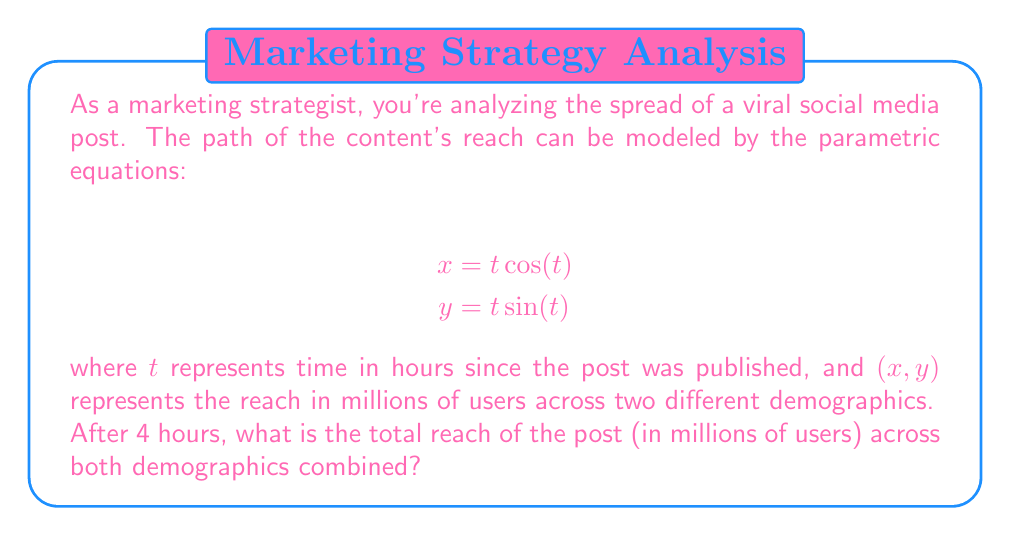Can you solve this math problem? To solve this problem, we need to follow these steps:

1) First, we need to calculate the x and y coordinates at t = 4 hours:

   For x: $x = t \cos(t) = 4 \cos(4)$
   For y: $y = t \sin(t) = 4 \sin(4)$

2) To find the actual values, we need to evaluate these:

   $x = 4 \cos(4) \approx -1.5136$ million users
   $y = 4 \sin(4) \approx 3.6370$ million users

3) The total reach is the distance from the origin to this point, which we can calculate using the Pythagorean theorem:

   $$\text{Total Reach} = \sqrt{x^2 + y^2}$$

4) Substituting our values:

   $$\text{Total Reach} = \sqrt{(-1.5136)^2 + (3.6370)^2}$$

5) Calculating:

   $$\text{Total Reach} = \sqrt{2.2910 + 13.2278} = \sqrt{15.5188} \approx 3.9394$$

Therefore, after 4 hours, the total reach of the post is approximately 3.9394 million users.

This spiral pattern is typical of viral content spread, where the reach expands rapidly at first and then starts to slow down as it saturates the potential audience.
Answer: 3.9394 million users 